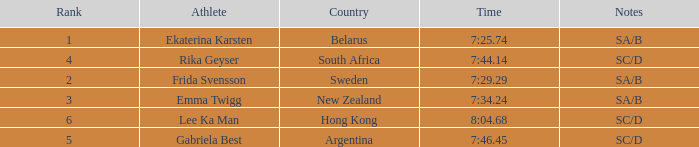What is the race time for emma twigg? 7:34.24. 